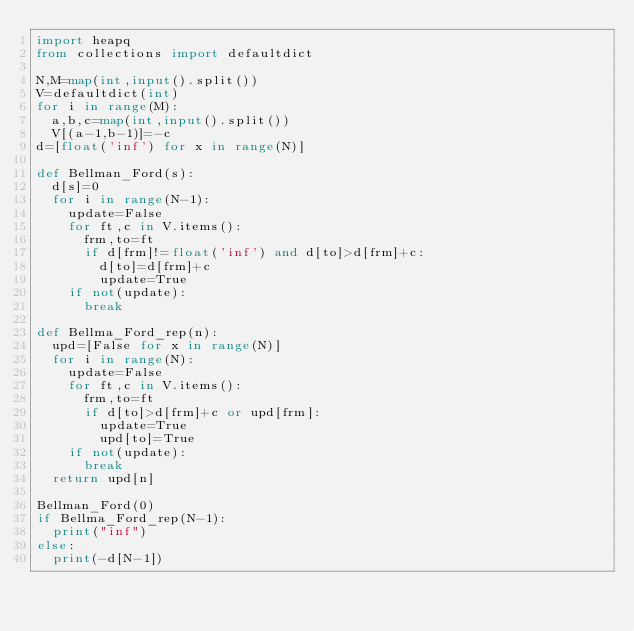<code> <loc_0><loc_0><loc_500><loc_500><_Python_>import heapq
from collections import defaultdict

N,M=map(int,input().split())
V=defaultdict(int)
for i in range(M):
  a,b,c=map(int,input().split())
  V[(a-1,b-1)]=-c
d=[float('inf') for x in range(N)]

def Bellman_Ford(s):
  d[s]=0
  for i in range(N-1):
    update=False
    for ft,c in V.items():
      frm,to=ft
      if d[frm]!=float('inf') and d[to]>d[frm]+c:
        d[to]=d[frm]+c
        update=True
    if not(update):
      break
  
def Bellma_Ford_rep(n):
  upd=[False for x in range(N)]
  for i in range(N):
    update=False
    for ft,c in V.items():
      frm,to=ft
      if d[to]>d[frm]+c or upd[frm]:
        update=True
        upd[to]=True
    if not(update):
      break
  return upd[n]

Bellman_Ford(0)
if Bellma_Ford_rep(N-1):
  print("inf")
else:
  print(-d[N-1])</code> 